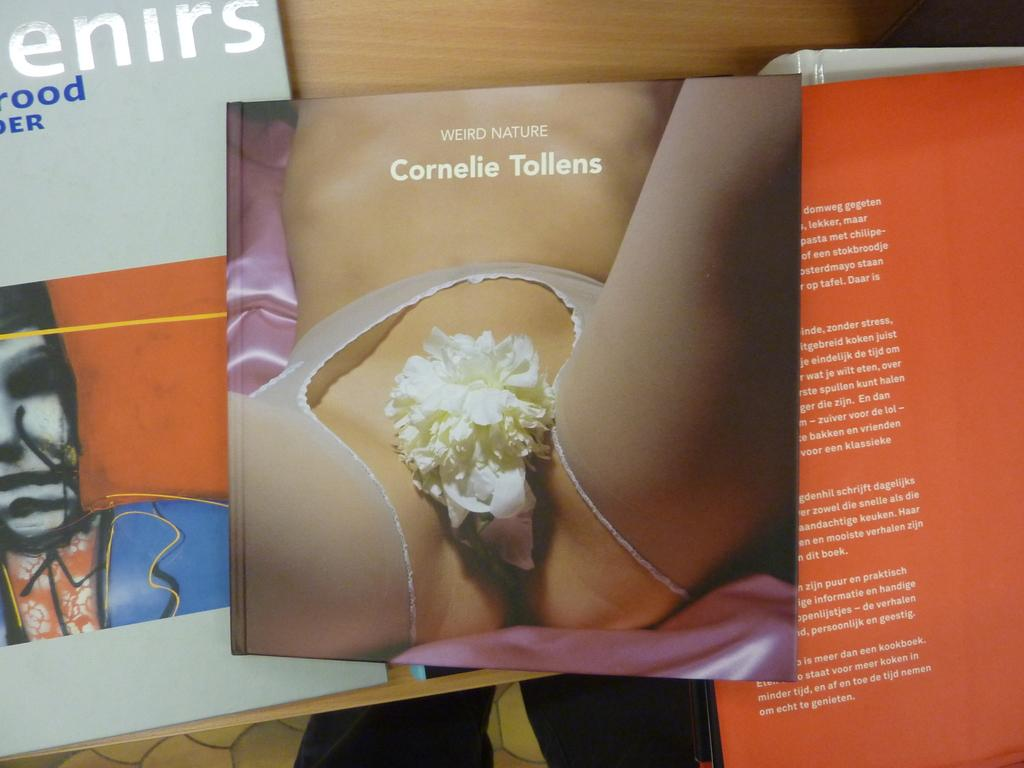<image>
Write a terse but informative summary of the picture. A book has a very revealing photo on the cover, was written by Cornelie Tollens, and is titled Weird Nature. 